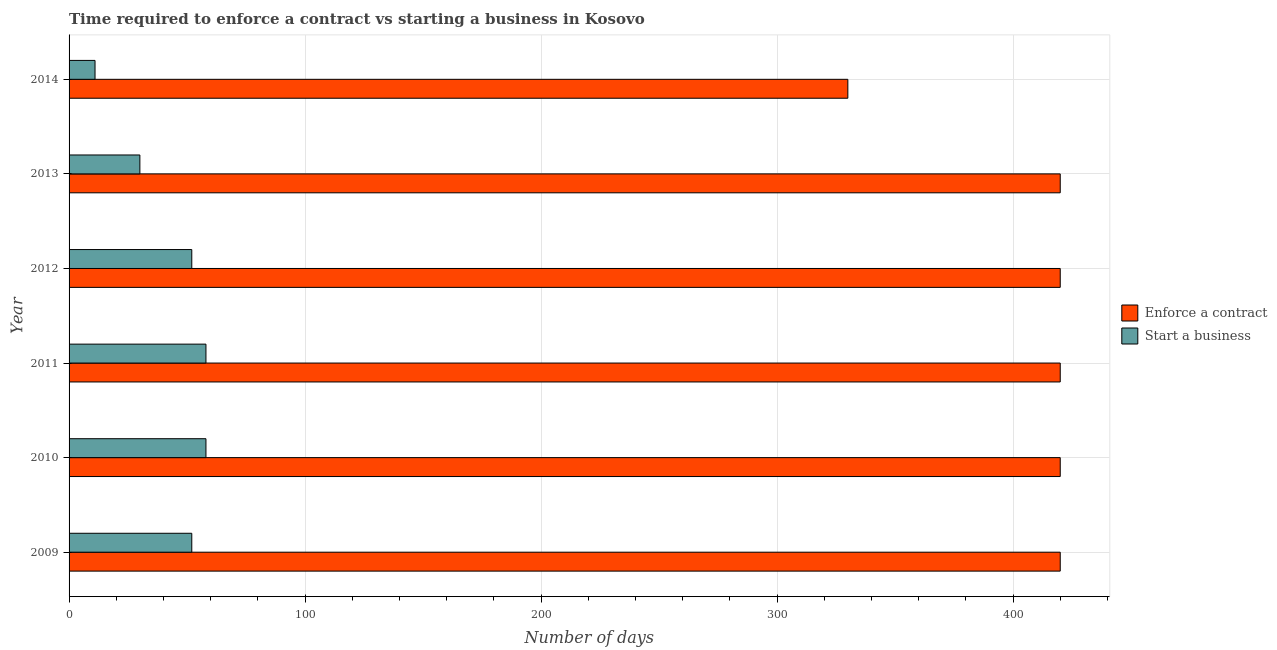How many groups of bars are there?
Your response must be concise. 6. Are the number of bars per tick equal to the number of legend labels?
Make the answer very short. Yes. How many bars are there on the 1st tick from the top?
Your answer should be very brief. 2. In how many cases, is the number of bars for a given year not equal to the number of legend labels?
Give a very brief answer. 0. What is the number of days to enforece a contract in 2009?
Make the answer very short. 420. Across all years, what is the maximum number of days to start a business?
Give a very brief answer. 58. Across all years, what is the minimum number of days to start a business?
Provide a succinct answer. 11. What is the total number of days to start a business in the graph?
Your answer should be compact. 261. What is the difference between the number of days to enforece a contract in 2010 and that in 2014?
Keep it short and to the point. 90. What is the difference between the number of days to start a business in 2012 and the number of days to enforece a contract in 2011?
Keep it short and to the point. -368. What is the average number of days to enforece a contract per year?
Provide a short and direct response. 405. In the year 2012, what is the difference between the number of days to enforece a contract and number of days to start a business?
Provide a short and direct response. 368. In how many years, is the number of days to start a business greater than 40 days?
Provide a short and direct response. 4. What is the ratio of the number of days to enforece a contract in 2010 to that in 2014?
Provide a short and direct response. 1.27. Is the difference between the number of days to enforece a contract in 2011 and 2014 greater than the difference between the number of days to start a business in 2011 and 2014?
Make the answer very short. Yes. What is the difference between the highest and the lowest number of days to start a business?
Your answer should be compact. 47. In how many years, is the number of days to enforece a contract greater than the average number of days to enforece a contract taken over all years?
Ensure brevity in your answer.  5. What does the 1st bar from the top in 2009 represents?
Keep it short and to the point. Start a business. What does the 2nd bar from the bottom in 2009 represents?
Your response must be concise. Start a business. How many years are there in the graph?
Your answer should be very brief. 6. What is the title of the graph?
Your response must be concise. Time required to enforce a contract vs starting a business in Kosovo. Does "Female entrants" appear as one of the legend labels in the graph?
Your answer should be compact. No. What is the label or title of the X-axis?
Provide a short and direct response. Number of days. What is the Number of days in Enforce a contract in 2009?
Give a very brief answer. 420. What is the Number of days in Start a business in 2009?
Your answer should be very brief. 52. What is the Number of days of Enforce a contract in 2010?
Ensure brevity in your answer.  420. What is the Number of days in Enforce a contract in 2011?
Offer a terse response. 420. What is the Number of days of Enforce a contract in 2012?
Offer a terse response. 420. What is the Number of days of Enforce a contract in 2013?
Offer a very short reply. 420. What is the Number of days in Start a business in 2013?
Provide a succinct answer. 30. What is the Number of days in Enforce a contract in 2014?
Provide a succinct answer. 330. Across all years, what is the maximum Number of days in Enforce a contract?
Provide a short and direct response. 420. Across all years, what is the minimum Number of days in Enforce a contract?
Your answer should be compact. 330. What is the total Number of days in Enforce a contract in the graph?
Offer a terse response. 2430. What is the total Number of days of Start a business in the graph?
Your answer should be very brief. 261. What is the difference between the Number of days of Enforce a contract in 2009 and that in 2010?
Keep it short and to the point. 0. What is the difference between the Number of days in Start a business in 2009 and that in 2010?
Provide a short and direct response. -6. What is the difference between the Number of days in Enforce a contract in 2009 and that in 2011?
Your response must be concise. 0. What is the difference between the Number of days of Start a business in 2009 and that in 2011?
Your answer should be very brief. -6. What is the difference between the Number of days of Enforce a contract in 2009 and that in 2012?
Your response must be concise. 0. What is the difference between the Number of days of Start a business in 2009 and that in 2012?
Make the answer very short. 0. What is the difference between the Number of days in Enforce a contract in 2009 and that in 2013?
Provide a short and direct response. 0. What is the difference between the Number of days in Start a business in 2010 and that in 2011?
Your answer should be very brief. 0. What is the difference between the Number of days in Enforce a contract in 2010 and that in 2012?
Keep it short and to the point. 0. What is the difference between the Number of days in Start a business in 2010 and that in 2012?
Your response must be concise. 6. What is the difference between the Number of days in Start a business in 2010 and that in 2013?
Provide a short and direct response. 28. What is the difference between the Number of days in Enforce a contract in 2011 and that in 2012?
Make the answer very short. 0. What is the difference between the Number of days of Enforce a contract in 2011 and that in 2013?
Ensure brevity in your answer.  0. What is the difference between the Number of days of Enforce a contract in 2012 and that in 2014?
Provide a succinct answer. 90. What is the difference between the Number of days in Start a business in 2012 and that in 2014?
Ensure brevity in your answer.  41. What is the difference between the Number of days of Enforce a contract in 2013 and that in 2014?
Keep it short and to the point. 90. What is the difference between the Number of days in Enforce a contract in 2009 and the Number of days in Start a business in 2010?
Ensure brevity in your answer.  362. What is the difference between the Number of days of Enforce a contract in 2009 and the Number of days of Start a business in 2011?
Your answer should be very brief. 362. What is the difference between the Number of days in Enforce a contract in 2009 and the Number of days in Start a business in 2012?
Provide a short and direct response. 368. What is the difference between the Number of days of Enforce a contract in 2009 and the Number of days of Start a business in 2013?
Ensure brevity in your answer.  390. What is the difference between the Number of days in Enforce a contract in 2009 and the Number of days in Start a business in 2014?
Your response must be concise. 409. What is the difference between the Number of days in Enforce a contract in 2010 and the Number of days in Start a business in 2011?
Ensure brevity in your answer.  362. What is the difference between the Number of days in Enforce a contract in 2010 and the Number of days in Start a business in 2012?
Offer a terse response. 368. What is the difference between the Number of days in Enforce a contract in 2010 and the Number of days in Start a business in 2013?
Ensure brevity in your answer.  390. What is the difference between the Number of days of Enforce a contract in 2010 and the Number of days of Start a business in 2014?
Ensure brevity in your answer.  409. What is the difference between the Number of days in Enforce a contract in 2011 and the Number of days in Start a business in 2012?
Your answer should be very brief. 368. What is the difference between the Number of days in Enforce a contract in 2011 and the Number of days in Start a business in 2013?
Give a very brief answer. 390. What is the difference between the Number of days of Enforce a contract in 2011 and the Number of days of Start a business in 2014?
Keep it short and to the point. 409. What is the difference between the Number of days of Enforce a contract in 2012 and the Number of days of Start a business in 2013?
Offer a terse response. 390. What is the difference between the Number of days in Enforce a contract in 2012 and the Number of days in Start a business in 2014?
Provide a succinct answer. 409. What is the difference between the Number of days in Enforce a contract in 2013 and the Number of days in Start a business in 2014?
Your response must be concise. 409. What is the average Number of days in Enforce a contract per year?
Make the answer very short. 405. What is the average Number of days of Start a business per year?
Ensure brevity in your answer.  43.5. In the year 2009, what is the difference between the Number of days of Enforce a contract and Number of days of Start a business?
Make the answer very short. 368. In the year 2010, what is the difference between the Number of days of Enforce a contract and Number of days of Start a business?
Your response must be concise. 362. In the year 2011, what is the difference between the Number of days of Enforce a contract and Number of days of Start a business?
Keep it short and to the point. 362. In the year 2012, what is the difference between the Number of days in Enforce a contract and Number of days in Start a business?
Your response must be concise. 368. In the year 2013, what is the difference between the Number of days in Enforce a contract and Number of days in Start a business?
Offer a terse response. 390. In the year 2014, what is the difference between the Number of days in Enforce a contract and Number of days in Start a business?
Keep it short and to the point. 319. What is the ratio of the Number of days of Start a business in 2009 to that in 2010?
Keep it short and to the point. 0.9. What is the ratio of the Number of days in Start a business in 2009 to that in 2011?
Your response must be concise. 0.9. What is the ratio of the Number of days of Enforce a contract in 2009 to that in 2012?
Provide a short and direct response. 1. What is the ratio of the Number of days in Start a business in 2009 to that in 2013?
Your response must be concise. 1.73. What is the ratio of the Number of days in Enforce a contract in 2009 to that in 2014?
Give a very brief answer. 1.27. What is the ratio of the Number of days of Start a business in 2009 to that in 2014?
Your answer should be compact. 4.73. What is the ratio of the Number of days in Enforce a contract in 2010 to that in 2011?
Offer a very short reply. 1. What is the ratio of the Number of days of Enforce a contract in 2010 to that in 2012?
Provide a short and direct response. 1. What is the ratio of the Number of days in Start a business in 2010 to that in 2012?
Give a very brief answer. 1.12. What is the ratio of the Number of days in Start a business in 2010 to that in 2013?
Offer a terse response. 1.93. What is the ratio of the Number of days in Enforce a contract in 2010 to that in 2014?
Keep it short and to the point. 1.27. What is the ratio of the Number of days in Start a business in 2010 to that in 2014?
Make the answer very short. 5.27. What is the ratio of the Number of days in Start a business in 2011 to that in 2012?
Offer a terse response. 1.12. What is the ratio of the Number of days of Start a business in 2011 to that in 2013?
Offer a very short reply. 1.93. What is the ratio of the Number of days of Enforce a contract in 2011 to that in 2014?
Your answer should be very brief. 1.27. What is the ratio of the Number of days in Start a business in 2011 to that in 2014?
Your response must be concise. 5.27. What is the ratio of the Number of days in Enforce a contract in 2012 to that in 2013?
Your answer should be very brief. 1. What is the ratio of the Number of days in Start a business in 2012 to that in 2013?
Your answer should be compact. 1.73. What is the ratio of the Number of days in Enforce a contract in 2012 to that in 2014?
Provide a succinct answer. 1.27. What is the ratio of the Number of days of Start a business in 2012 to that in 2014?
Offer a very short reply. 4.73. What is the ratio of the Number of days of Enforce a contract in 2013 to that in 2014?
Your answer should be compact. 1.27. What is the ratio of the Number of days in Start a business in 2013 to that in 2014?
Your answer should be very brief. 2.73. What is the difference between the highest and the second highest Number of days of Start a business?
Provide a succinct answer. 0. What is the difference between the highest and the lowest Number of days of Start a business?
Provide a succinct answer. 47. 